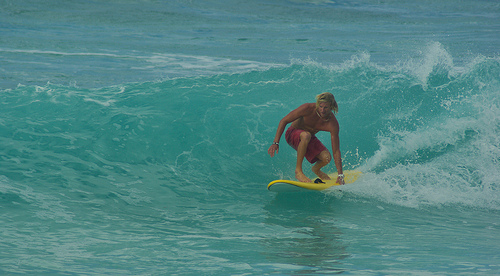What time of day does it appear to be in the image? It seems to be late afternoon, given the warm, soft lighting and the lengthening shadows cast on the water. 